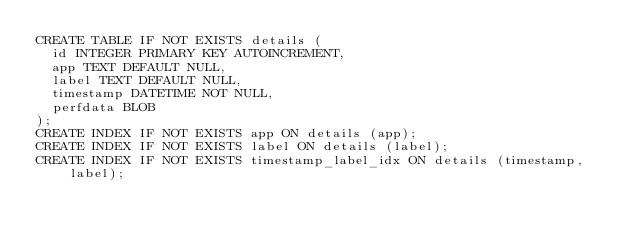Convert code to text. <code><loc_0><loc_0><loc_500><loc_500><_SQL_>CREATE TABLE IF NOT EXISTS details (
  id INTEGER PRIMARY KEY AUTOINCREMENT,
  app TEXT DEFAULT NULL,
  label TEXT DEFAULT NULL,
  timestamp DATETIME NOT NULL,
  perfdata BLOB
);
CREATE INDEX IF NOT EXISTS app ON details (app);
CREATE INDEX IF NOT EXISTS label ON details (label);
CREATE INDEX IF NOT EXISTS timestamp_label_idx ON details (timestamp,label);
</code> 